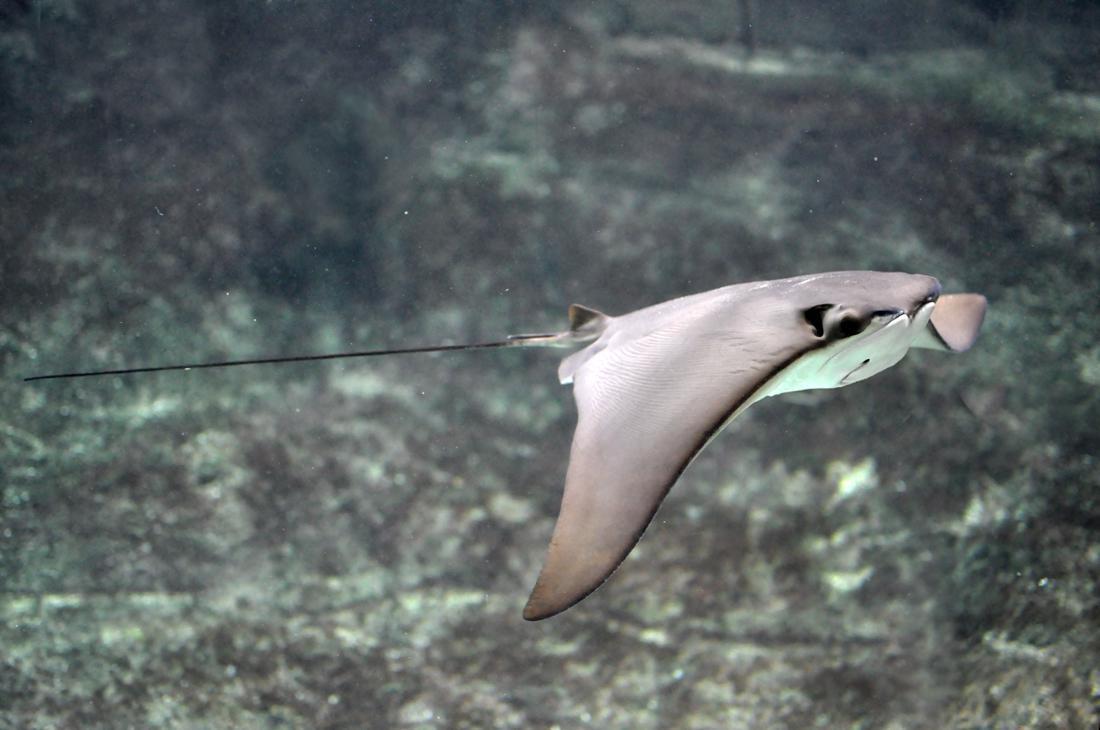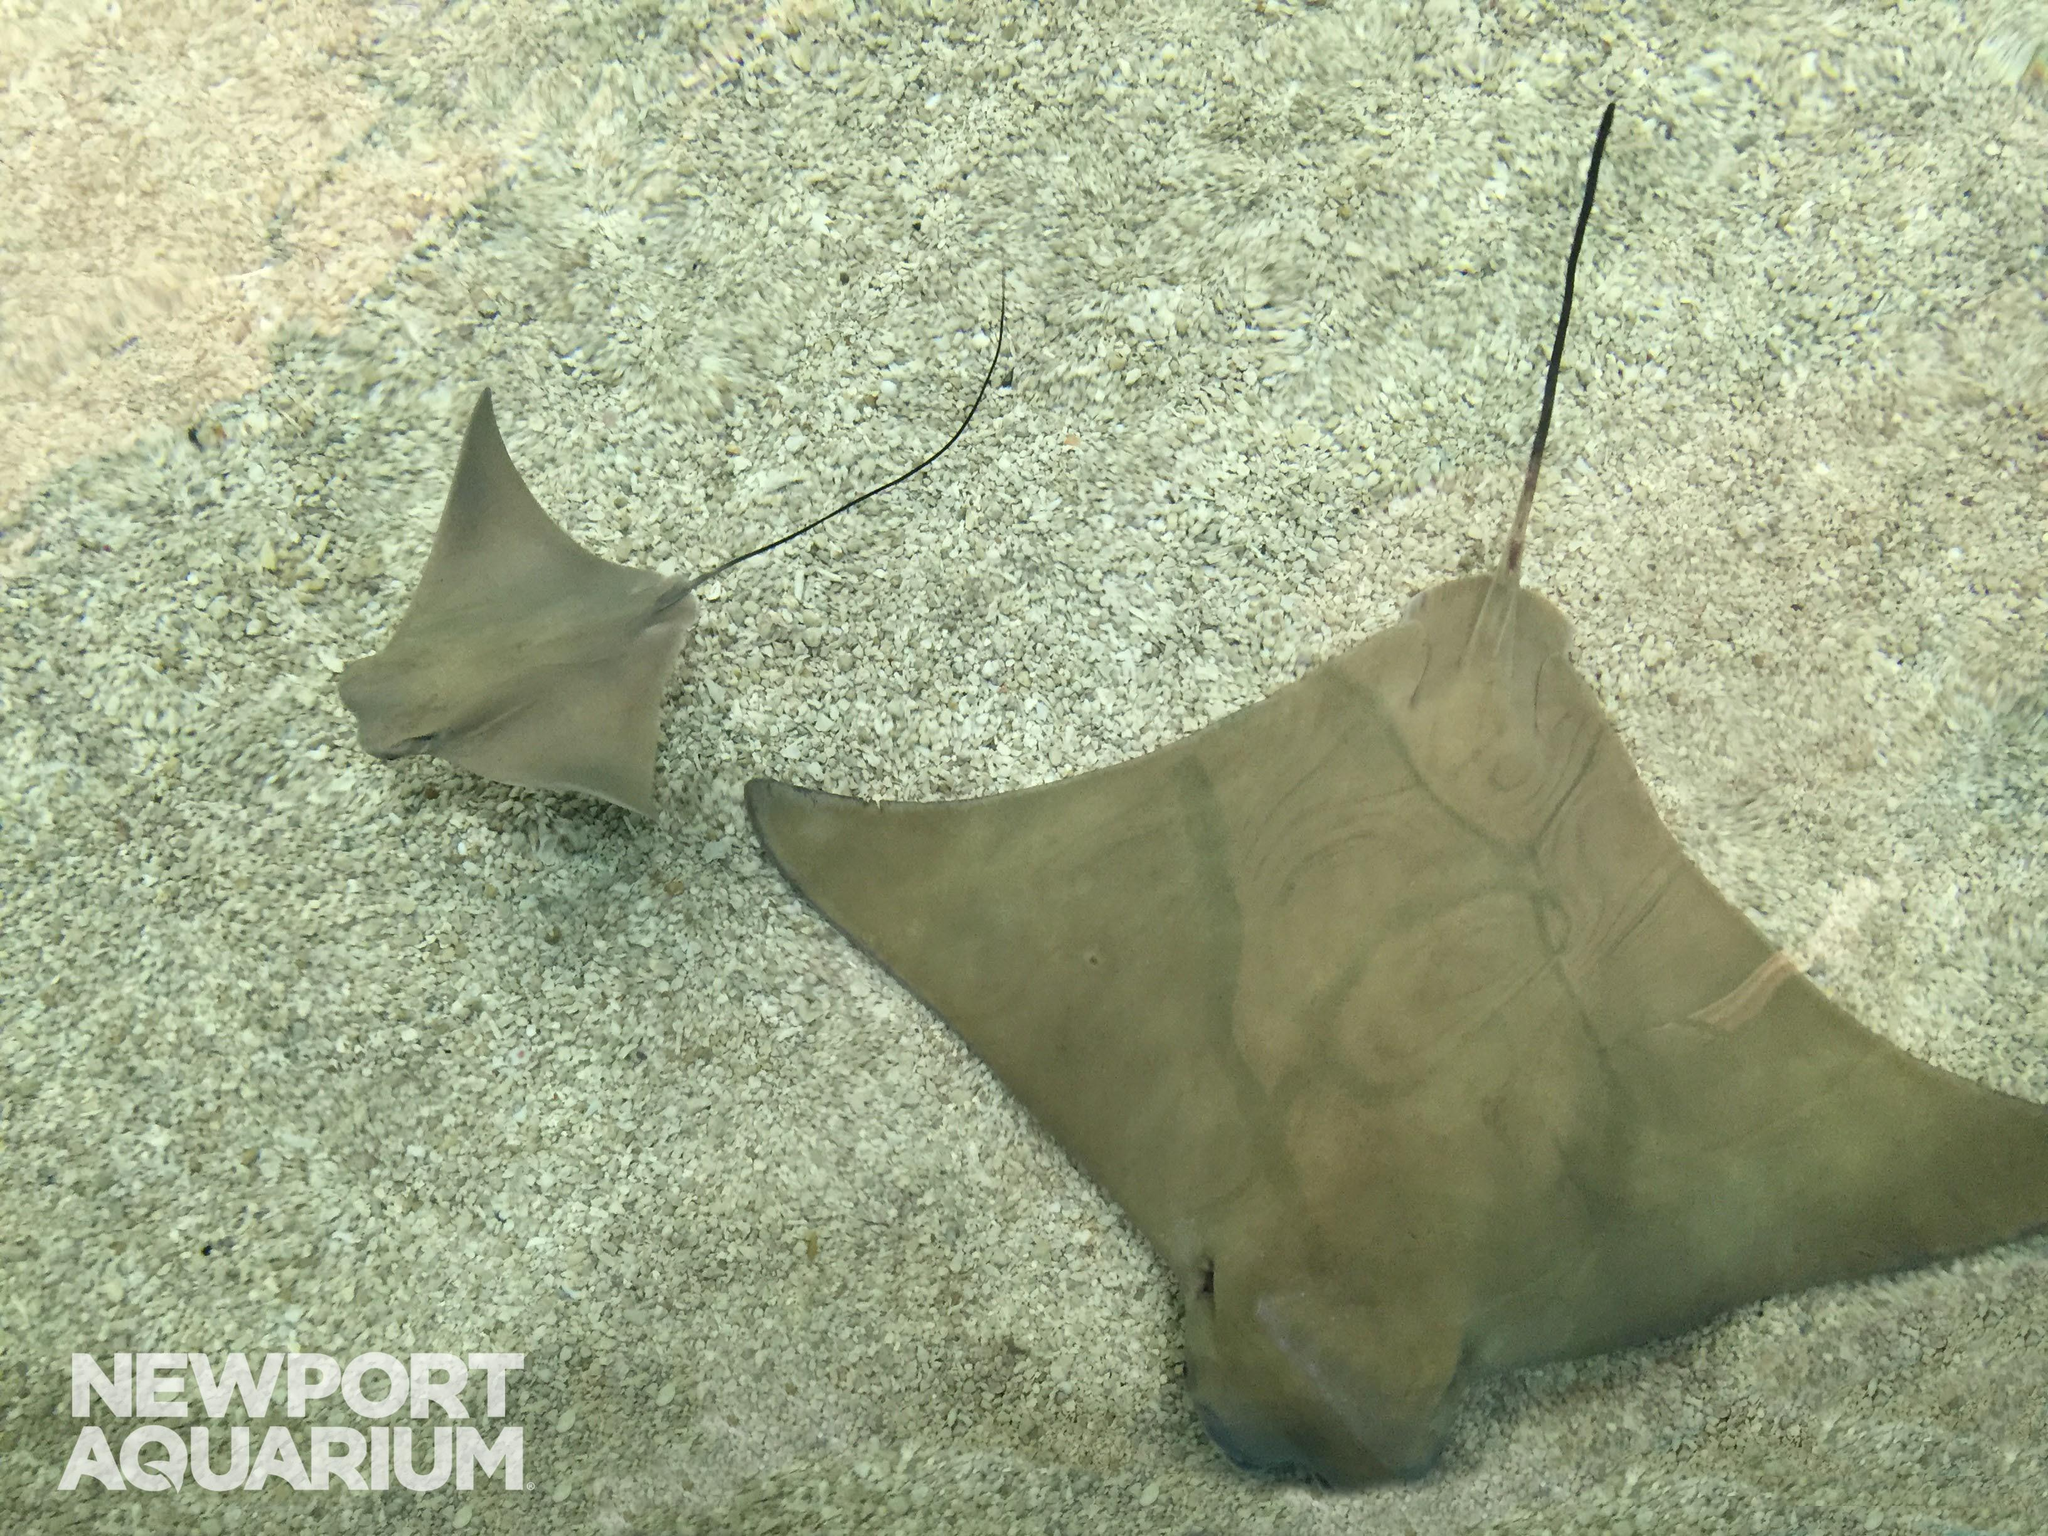The first image is the image on the left, the second image is the image on the right. Given the left and right images, does the statement "Has atleast one image with more than 2 stingrays" hold true? Answer yes or no. No. The first image is the image on the left, the second image is the image on the right. Assess this claim about the two images: "There are no more than 3 sting rays total.". Correct or not? Answer yes or no. Yes. 